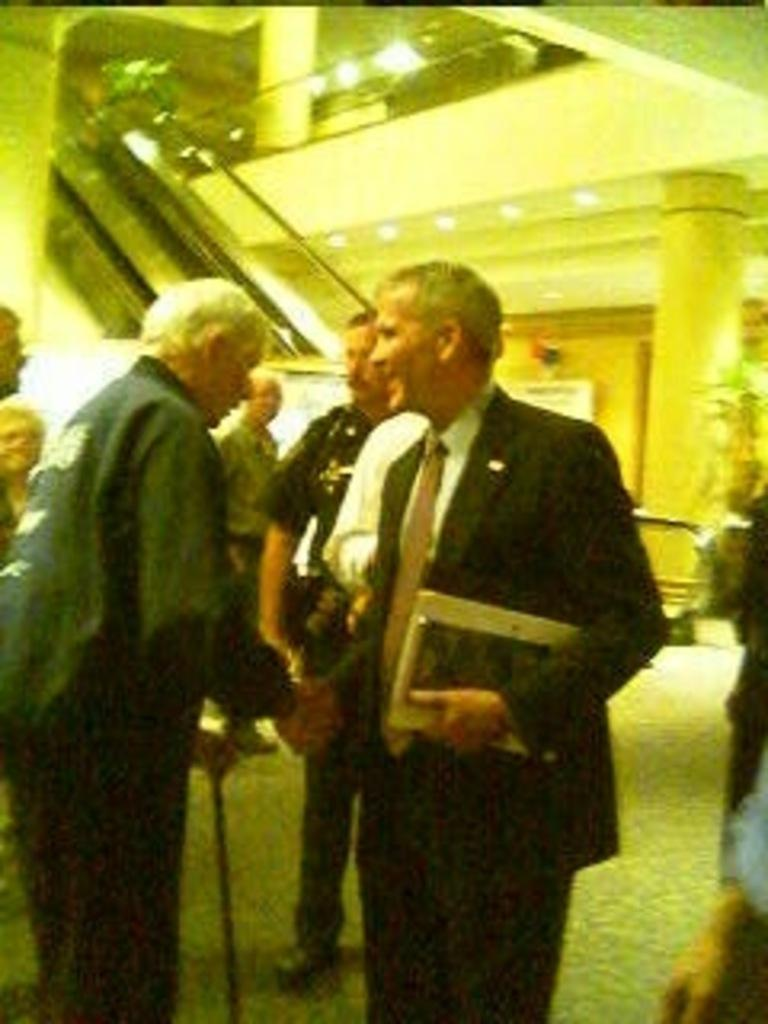How many people are in the image? There are two people in the image. What are the two people doing? The two people are standing and shaking hands. Can you describe the background of the image? There are other people in the background of the image. Where is the judge sitting in the image? There is no judge present in the image. How many cats can be seen in the image? There are no cats present in the image. 